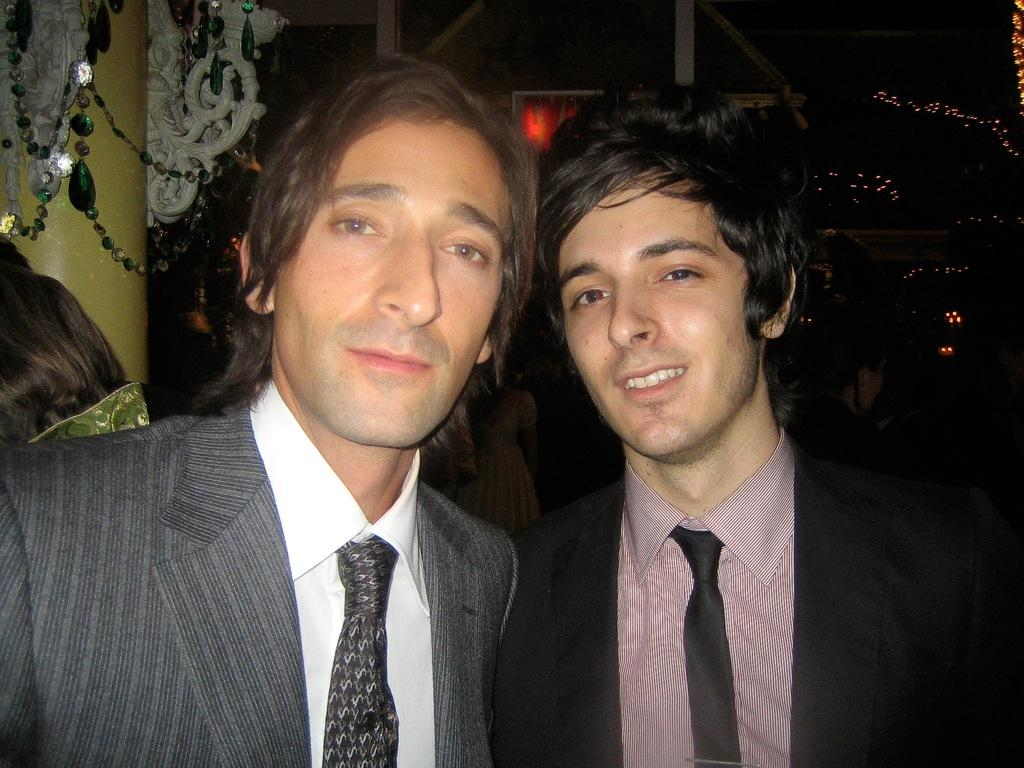How many people are in the image? There are two persons standing in the center of the image. What are the persons wearing? Both persons are wearing suits and ties. What can be seen in the background of the image? There is a wall, decor, and lights in the background of the image. What type of cheese is being served in the hospital room in the image? There is no cheese or hospital room present in the image. 